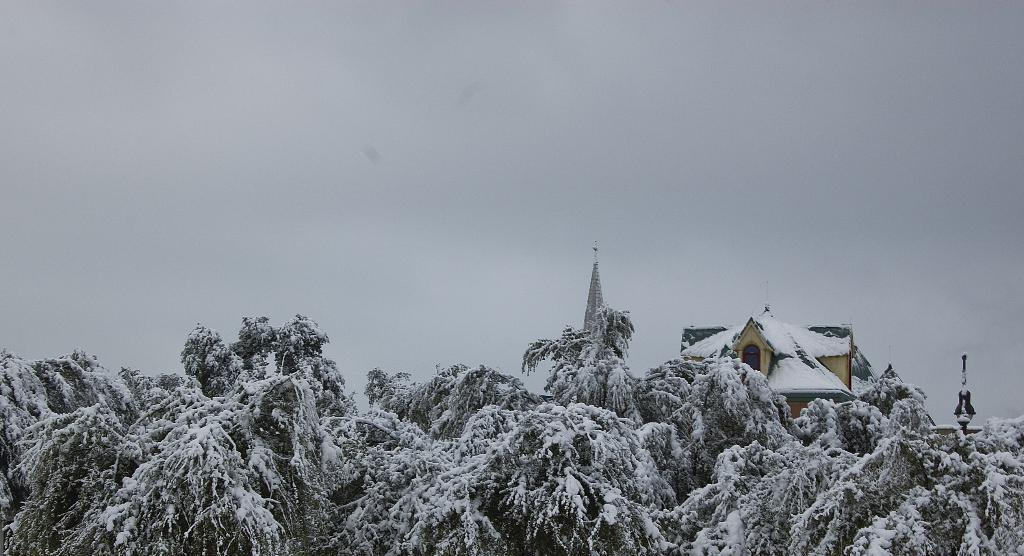What type of vegetation is present in the image? There are trees in the image. What is covering the trees in the image? There is snow on the trees. What structure can be seen in the background of the image? There is a house in the background of the image. What is the condition of the sky in the image? The sky is cloudy at the top of the image. How many sisters are holding cameras in the image? There are no sisters or cameras present in the image. What type of frogs can be seen hopping on the snow-covered trees? There are no frogs present in the image; it only features trees with snow on them. 